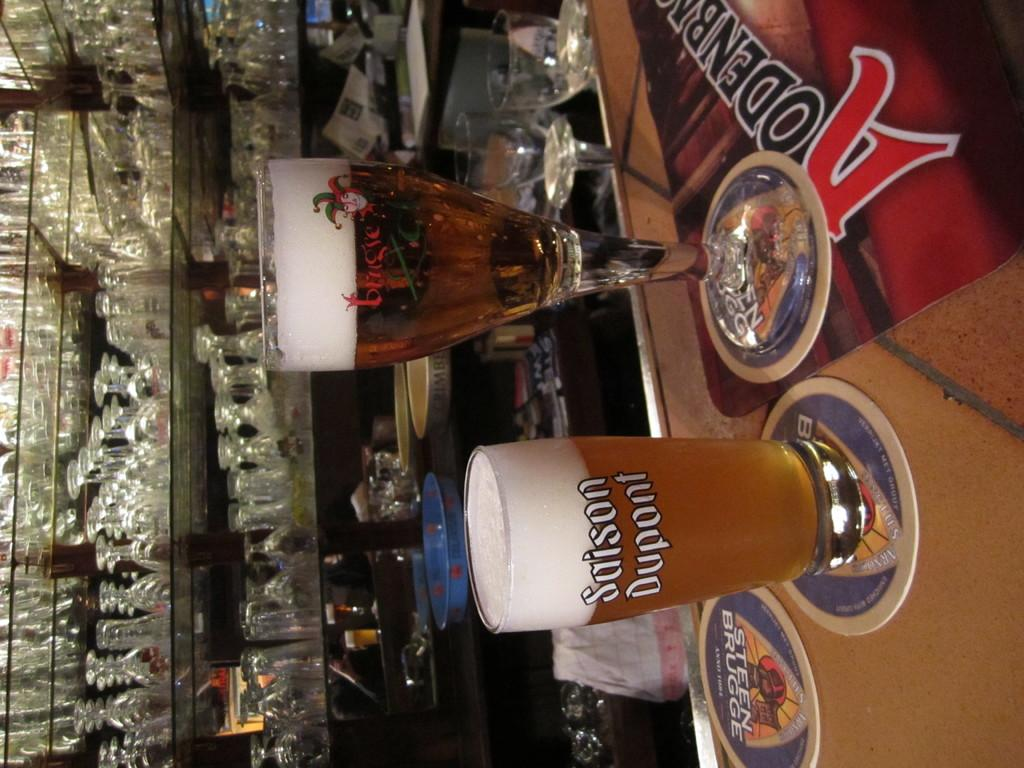Provide a one-sentence caption for the provided image. two glasses of beer with Sason dupont on the short one, are sitting on a bar. 